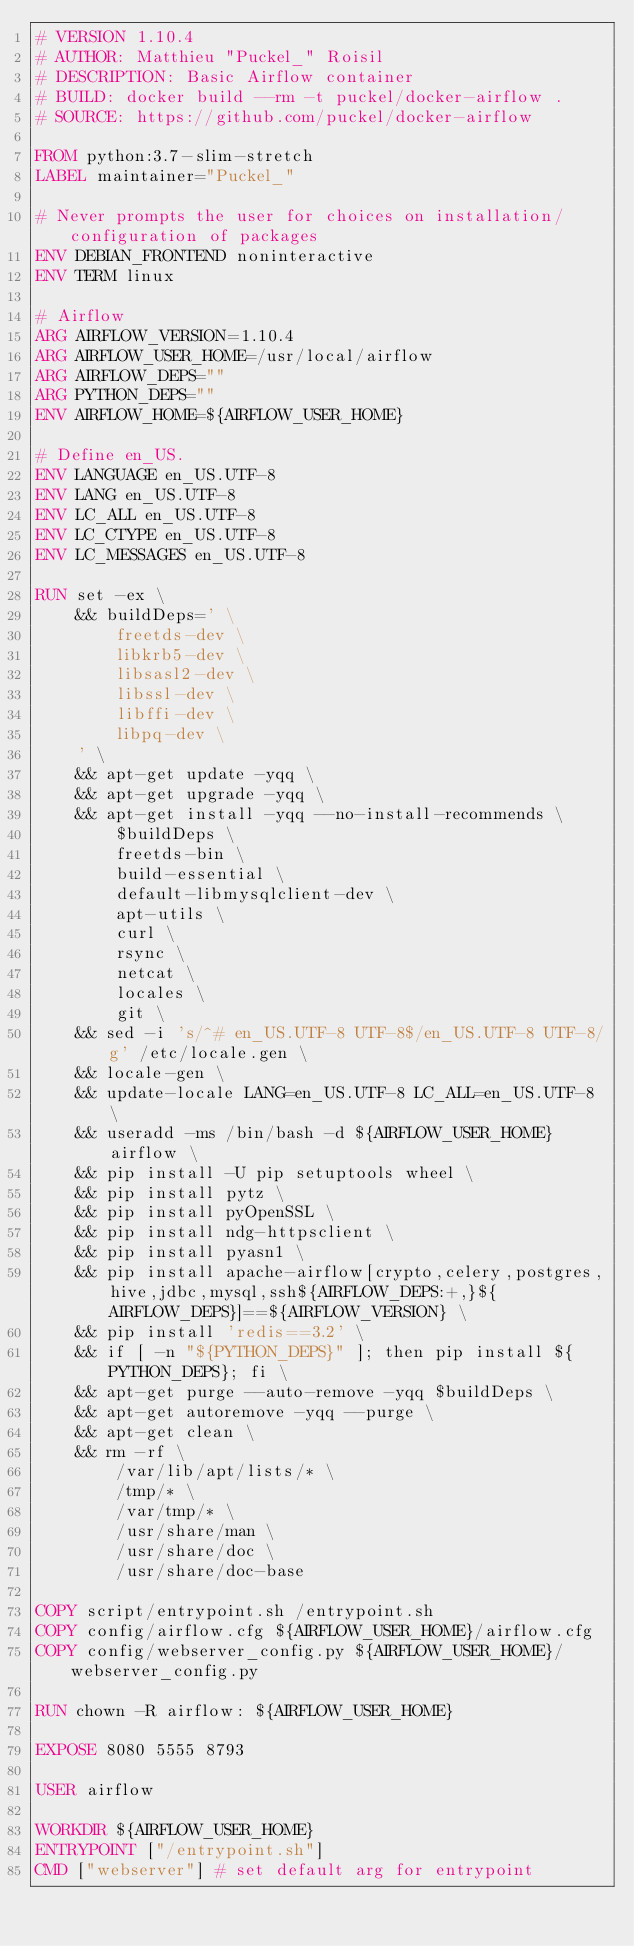<code> <loc_0><loc_0><loc_500><loc_500><_Dockerfile_># VERSION 1.10.4
# AUTHOR: Matthieu "Puckel_" Roisil
# DESCRIPTION: Basic Airflow container
# BUILD: docker build --rm -t puckel/docker-airflow .
# SOURCE: https://github.com/puckel/docker-airflow

FROM python:3.7-slim-stretch
LABEL maintainer="Puckel_"

# Never prompts the user for choices on installation/configuration of packages
ENV DEBIAN_FRONTEND noninteractive
ENV TERM linux

# Airflow
ARG AIRFLOW_VERSION=1.10.4
ARG AIRFLOW_USER_HOME=/usr/local/airflow
ARG AIRFLOW_DEPS=""
ARG PYTHON_DEPS=""
ENV AIRFLOW_HOME=${AIRFLOW_USER_HOME}

# Define en_US.
ENV LANGUAGE en_US.UTF-8
ENV LANG en_US.UTF-8
ENV LC_ALL en_US.UTF-8
ENV LC_CTYPE en_US.UTF-8
ENV LC_MESSAGES en_US.UTF-8

RUN set -ex \
    && buildDeps=' \
        freetds-dev \
        libkrb5-dev \
        libsasl2-dev \
        libssl-dev \
        libffi-dev \
        libpq-dev \
    ' \
    && apt-get update -yqq \
    && apt-get upgrade -yqq \
    && apt-get install -yqq --no-install-recommends \
        $buildDeps \
        freetds-bin \
        build-essential \
        default-libmysqlclient-dev \
        apt-utils \
        curl \
        rsync \
        netcat \
        locales \
        git \
    && sed -i 's/^# en_US.UTF-8 UTF-8$/en_US.UTF-8 UTF-8/g' /etc/locale.gen \
    && locale-gen \
    && update-locale LANG=en_US.UTF-8 LC_ALL=en_US.UTF-8 \
    && useradd -ms /bin/bash -d ${AIRFLOW_USER_HOME} airflow \
    && pip install -U pip setuptools wheel \
    && pip install pytz \
    && pip install pyOpenSSL \
    && pip install ndg-httpsclient \
    && pip install pyasn1 \
    && pip install apache-airflow[crypto,celery,postgres,hive,jdbc,mysql,ssh${AIRFLOW_DEPS:+,}${AIRFLOW_DEPS}]==${AIRFLOW_VERSION} \
    && pip install 'redis==3.2' \
    && if [ -n "${PYTHON_DEPS}" ]; then pip install ${PYTHON_DEPS}; fi \
    && apt-get purge --auto-remove -yqq $buildDeps \
    && apt-get autoremove -yqq --purge \
    && apt-get clean \
    && rm -rf \
        /var/lib/apt/lists/* \
        /tmp/* \
        /var/tmp/* \
        /usr/share/man \
        /usr/share/doc \
        /usr/share/doc-base

COPY script/entrypoint.sh /entrypoint.sh
COPY config/airflow.cfg ${AIRFLOW_USER_HOME}/airflow.cfg
COPY config/webserver_config.py ${AIRFLOW_USER_HOME}/webserver_config.py

RUN chown -R airflow: ${AIRFLOW_USER_HOME}

EXPOSE 8080 5555 8793

USER airflow

WORKDIR ${AIRFLOW_USER_HOME}
ENTRYPOINT ["/entrypoint.sh"]
CMD ["webserver"] # set default arg for entrypoint
</code> 